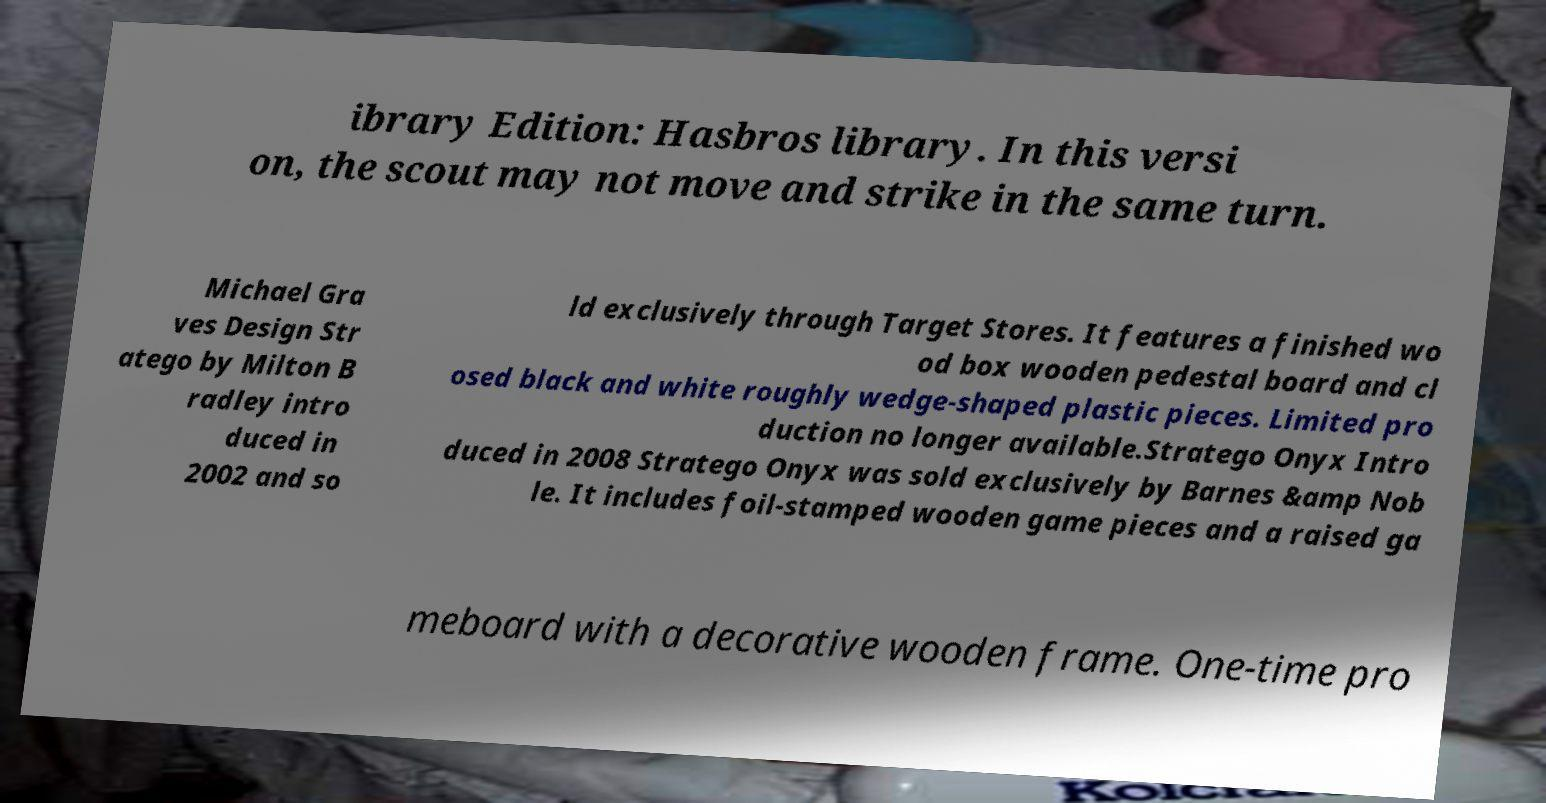Could you extract and type out the text from this image? ibrary Edition: Hasbros library. In this versi on, the scout may not move and strike in the same turn. Michael Gra ves Design Str atego by Milton B radley intro duced in 2002 and so ld exclusively through Target Stores. It features a finished wo od box wooden pedestal board and cl osed black and white roughly wedge-shaped plastic pieces. Limited pro duction no longer available.Stratego Onyx Intro duced in 2008 Stratego Onyx was sold exclusively by Barnes &amp Nob le. It includes foil-stamped wooden game pieces and a raised ga meboard with a decorative wooden frame. One-time pro 